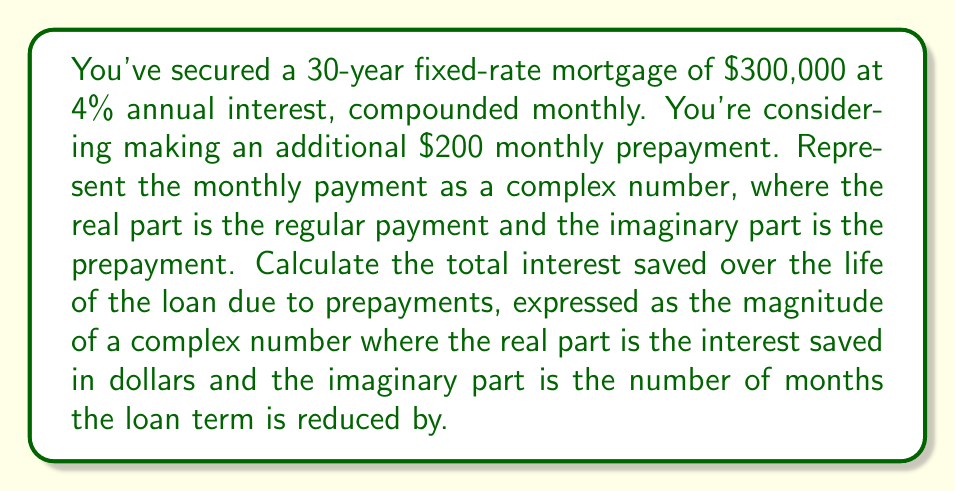Give your solution to this math problem. 1) First, calculate the regular monthly payment using the mortgage payment formula:
   $P = L \frac{r(1+r)^n}{(1+r)^n - 1}$
   Where:
   $L = 300000$ (loan amount)
   $r = \frac{0.04}{12} = 0.003333$ (monthly interest rate)
   $n = 360$ (total number of payments)

   $P = 300000 \frac{0.003333(1+0.003333)^{360}}{(1+0.003333)^{360} - 1} = 1432.25$

2) Represent the monthly payment as a complex number:
   $z = 1432.25 + 200i$

3) Calculate the new loan term with prepayments:
   Use a financial calculator or spreadsheet to determine that the loan will be paid off in approximately 277 months.

4) Calculate total interest paid without prepayments:
   $Total Interest = (1432.25 \times 360) - 300000 = 215610$

5) Calculate total interest paid with prepayments:
   $Total Interest with Prepayments = (1432.25 \times 277) + (200 \times 277) - 300000 = 146733.25$

6) Calculate interest saved:
   $Interest Saved = 215610 - 146733.25 = 68876.75$

7) Represent the result as a complex number:
   $w = 68876.75 + 83i$ (where 83 is the number of months reduced)

8) Calculate the magnitude of this complex number:
   $|w| = \sqrt{68876.75^2 + 83^2} = 68877.05$
Answer: $68877.05$ 